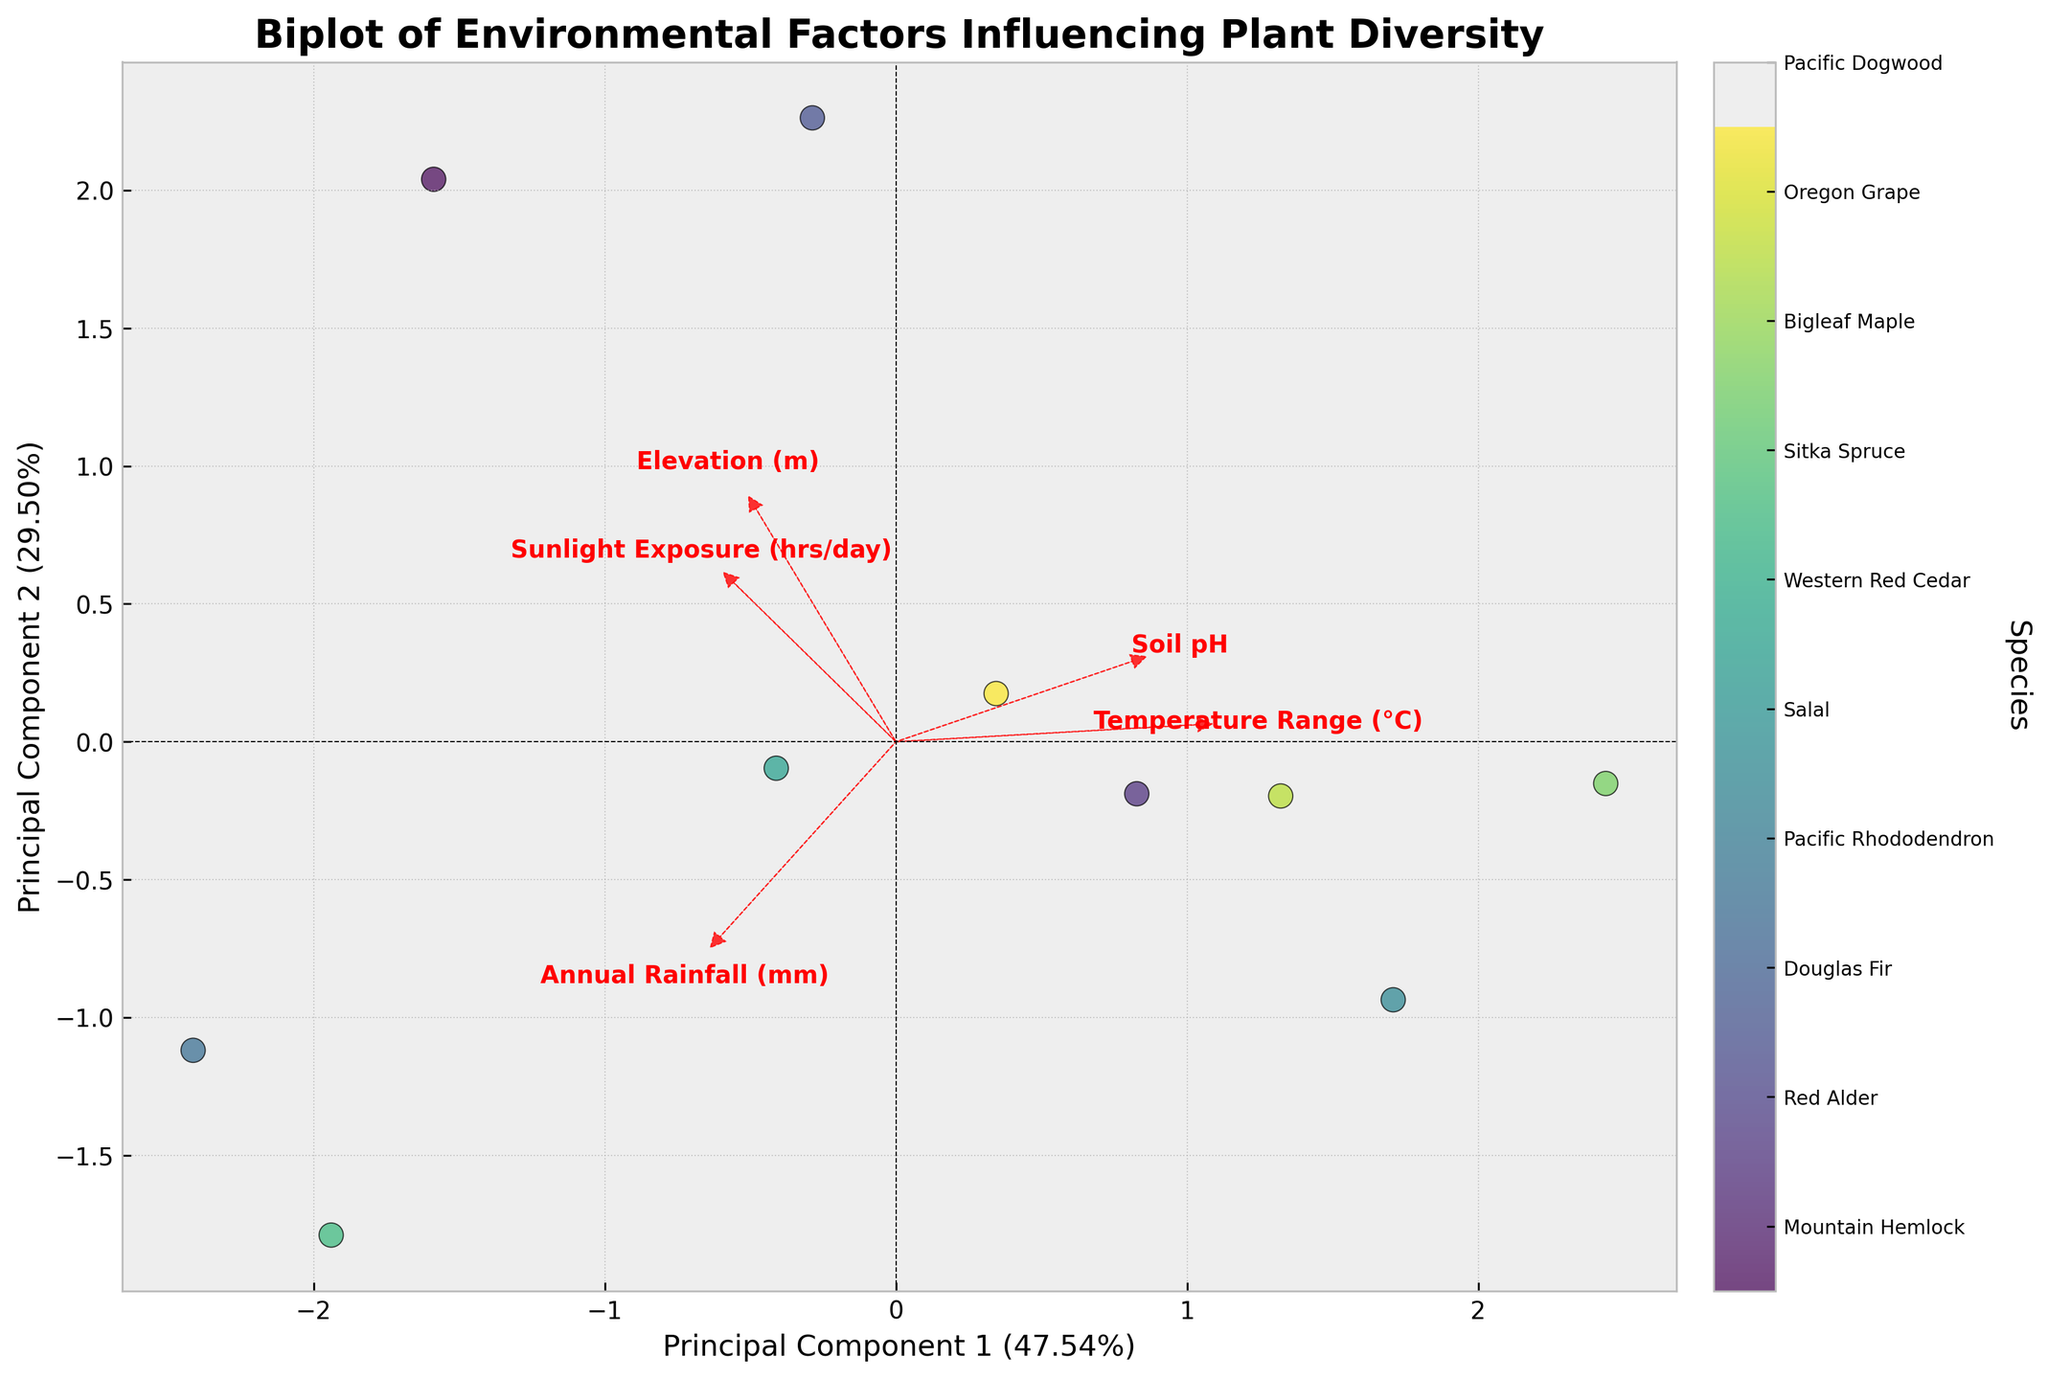What is the title of the biplot? The title is typically displayed at the top of a plot, providing a brief description of what the plot is about. In this case, the title is: "Biplot of Environmental Factors Influencing Plant Diversity".
Answer: "Biplot of Environmental Factors Influencing Plant Diversity" How many different species are represented in the biplot? The number of different species can be counted from the color legend or the colorbar on the plot, which should list each species' name. There are 10 species represented in the biplot.
Answer: 10 Which environmental factor has the longest loading vector in the biplot? The length of a loading vector indicates how strongly an environmental factor influences the principal components. By observing the length of each loading vector, it is clear that "Annual Rainfall (mm)" has the longest loading vector.
Answer: "Annual Rainfall (mm)" Between "Elevation (m)" and "Temperature Range (°C)", which factor is more aligned with Principal Component 1? Principal Component 1 is the x-axis of the biplot. The factors are depicted as arrows (loading vectors). The arrow for "Elevation (m)" points more horizontally compared to the arrow for "Temperature Range (°C)", indicating that "Elevation (m)" is more aligned with Principal Component 1.
Answer: "Elevation (m)" Which species is located closest to the origin of the biplot? The species closest to the origin (0,0) can be identified by locating the data point that is nearest to this point. In this case, "Western Red Cedar" is closest to the origin.
Answer: "Western Red Cedar" Which environmental factor is most aligned with Principal Component 2? Principal Component 2 is the y-axis of the biplot. The factor whose arrow is most vertical (pointing up or down) is most aligned with Principal Component 2. "Soil pH" has the most vertical loading vector, indicating its strong alignment with Principal Component 2.
Answer: "Soil pH" How do "Mountain Hemlock" and "Sitka Spruce" compare in terms of their association with "Annual Rainfall (mm)"? By examining the positions and directions of the loading vector for "Annual Rainfall (mm)" and the data points for these species, "Sitka Spruce" is more aligned with the direction of "Annual Rainfall (mm)" compared to "Mountain Hemlock", indicating a stronger association.
Answer: "Sitka Spruce" has a stronger association with "Annual Rainfall (mm)" What is the primary direction of the loading vector for "Sunlight Exposure (hrs/day)"? The direction of a loading vector is shown by the orientation of the arrow. The arrow for "Sunlight Exposure (hrs/day)" points towards the lower right section, indicating it primarily aligns positively with Principal Component 1 and negatively with Principal Component 2.
Answer: Lower right Can you identify a species that is closely associated with both high "Elevation (m)" and low "Soil pH"? To find a species associated with both factors, look for a data point near the intersection of the loading vectors for "Elevation (m)" and "Soil pH" where one vector is positive and the other is negative. "Mountain Hemlock" fits this description as it is near the required orientation of these vectors.
Answer: "Mountain Hemlock" What is the calculated variance explained by the first principal component? The variance explained by Principal Component 1 can be found in the label for the x-axis. It should read as a percentage. In this biplot, it is labeled as 31.91%.
Answer: 31.91% 